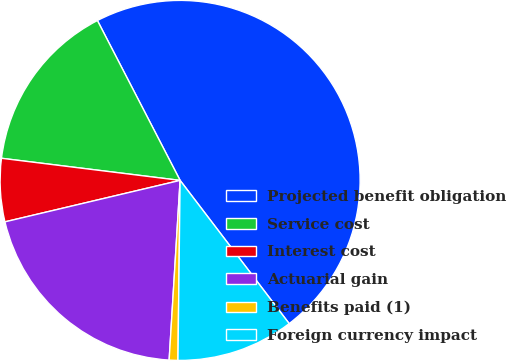Convert chart. <chart><loc_0><loc_0><loc_500><loc_500><pie_chart><fcel>Projected benefit obligation<fcel>Service cost<fcel>Interest cost<fcel>Actuarial gain<fcel>Benefits paid (1)<fcel>Foreign currency impact<nl><fcel>47.24%<fcel>15.44%<fcel>5.66%<fcel>20.33%<fcel>0.78%<fcel>10.55%<nl></chart> 